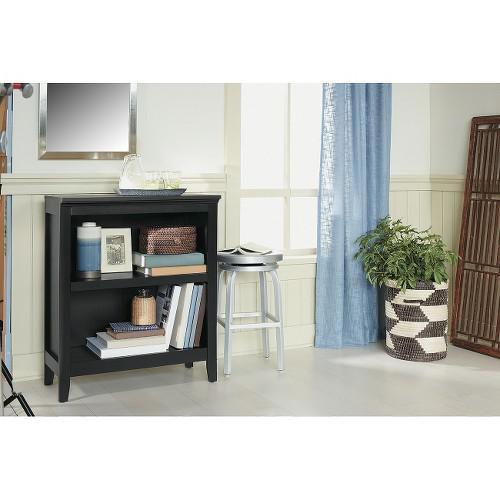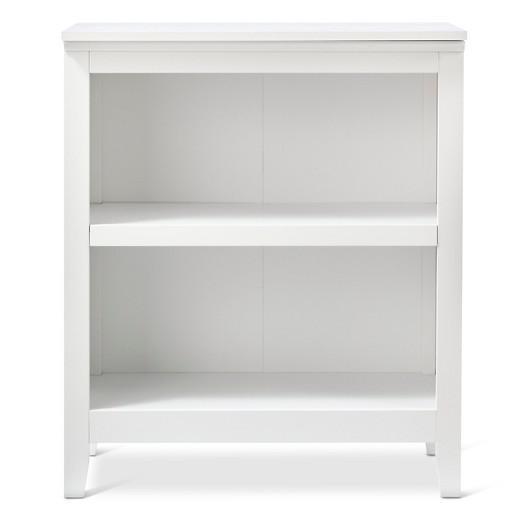The first image is the image on the left, the second image is the image on the right. For the images displayed, is the sentence "Each image shows one rectangular storage unit, with no other furniture and no storage contents." factually correct? Answer yes or no. No. 